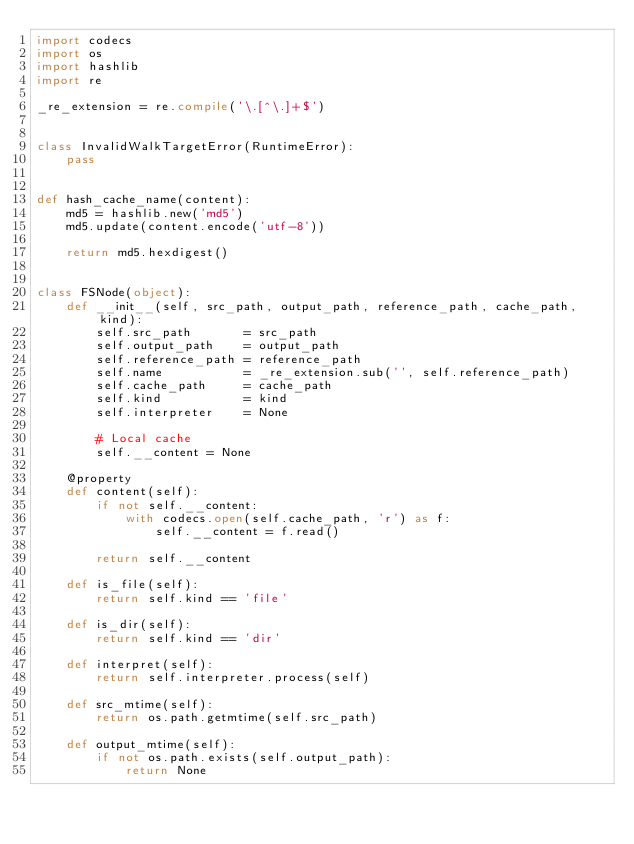<code> <loc_0><loc_0><loc_500><loc_500><_Python_>import codecs
import os
import hashlib
import re

_re_extension = re.compile('\.[^\.]+$')


class InvalidWalkTargetError(RuntimeError):
    pass


def hash_cache_name(content):
    md5 = hashlib.new('md5')
    md5.update(content.encode('utf-8'))

    return md5.hexdigest()


class FSNode(object):
    def __init__(self, src_path, output_path, reference_path, cache_path, kind):
        self.src_path       = src_path
        self.output_path    = output_path
        self.reference_path = reference_path
        self.name           = _re_extension.sub('', self.reference_path)
        self.cache_path     = cache_path
        self.kind           = kind
        self.interpreter    = None

        # Local cache
        self.__content = None

    @property
    def content(self):
        if not self.__content:
            with codecs.open(self.cache_path, 'r') as f:
                self.__content = f.read()

        return self.__content

    def is_file(self):
        return self.kind == 'file'

    def is_dir(self):
        return self.kind == 'dir'

    def interpret(self):
        return self.interpreter.process(self)

    def src_mtime(self):
        return os.path.getmtime(self.src_path)

    def output_mtime(self):
        if not os.path.exists(self.output_path):
            return None
</code> 